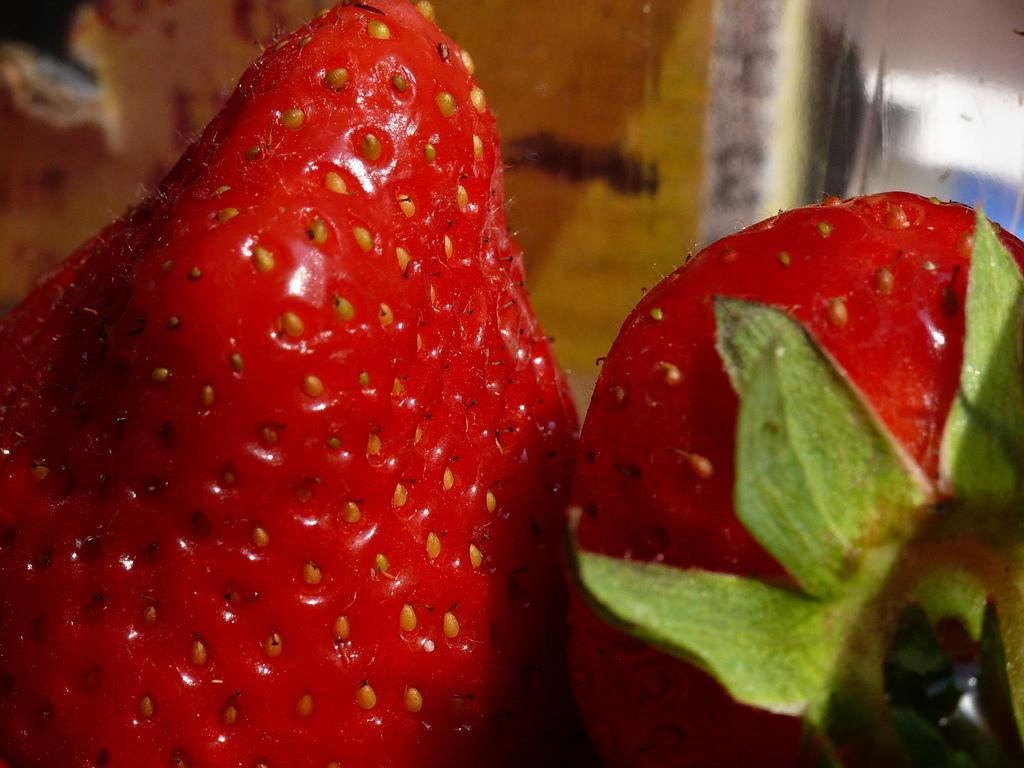Please provide a concise description of this image. In the image there are two berries and the background is blurry. 